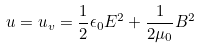Convert formula to latex. <formula><loc_0><loc_0><loc_500><loc_500>u = u _ { v } = \frac { 1 } { 2 } \epsilon _ { 0 } E ^ { 2 } + \frac { 1 } { 2 \mu _ { 0 } } B ^ { 2 }</formula> 